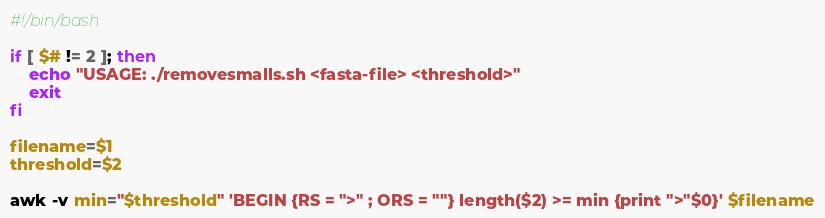Convert code to text. <code><loc_0><loc_0><loc_500><loc_500><_Bash_>#!/bin/bash

if [ $# != 2 ]; then
    echo "USAGE: ./removesmalls.sh <fasta-file> <threshold>"
    exit
fi

filename=$1
threshold=$2

awk -v min="$threshold" 'BEGIN {RS = ">" ; ORS = ""} length($2) >= min {print ">"$0}' $filename
</code> 